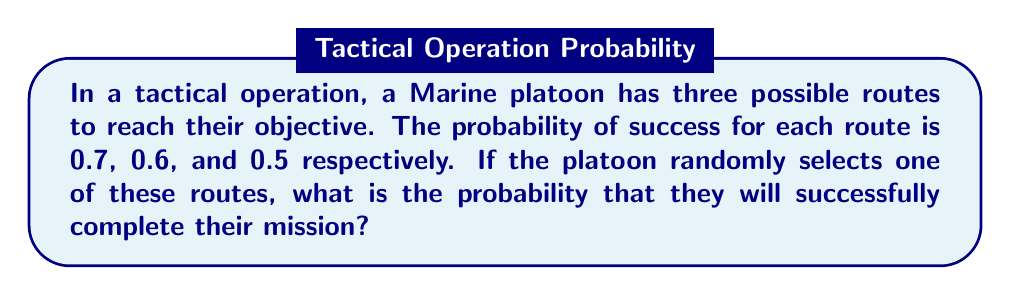Can you answer this question? Let's approach this step-by-step:

1) First, we need to understand what the question is asking. We're looking for the probability of success when one route is randomly chosen.

2) The probability of selecting each route is equal, as it's a random selection. With three routes, the probability of choosing any particular route is $\frac{1}{3}$.

3) Now, we can use the law of total probability. This states that the probability of an event is the sum of the probabilities of the event occurring in each possible scenario, multiplied by the probability of each scenario.

4) Let's define our events:
   $S$ = Success of the mission
   $R_1$, $R_2$, $R_3$ = Selection of route 1, 2, and 3 respectively

5) We can write our equation:

   $P(S) = P(S|R_1)P(R_1) + P(S|R_2)P(R_2) + P(S|R_3)P(R_3)$

6) Substituting our known values:

   $P(S) = 0.7 \cdot \frac{1}{3} + 0.6 \cdot \frac{1}{3} + 0.5 \cdot \frac{1}{3}$

7) Simplifying:

   $P(S) = \frac{0.7 + 0.6 + 0.5}{3} = \frac{1.8}{3} = 0.6$

Therefore, the probability of successfully completing the mission is 0.6 or 60%.
Answer: $0.6$ or $60\%$ 